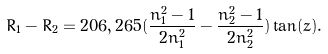Convert formula to latex. <formula><loc_0><loc_0><loc_500><loc_500>R _ { 1 } - R _ { 2 } = 2 0 6 , 2 6 5 ( \frac { n _ { 1 } ^ { 2 } - 1 } { 2 n _ { 1 } ^ { 2 } } - \frac { n _ { 2 } ^ { 2 } - 1 } { 2 n _ { 2 } ^ { 2 } } ) \tan ( z ) .</formula> 